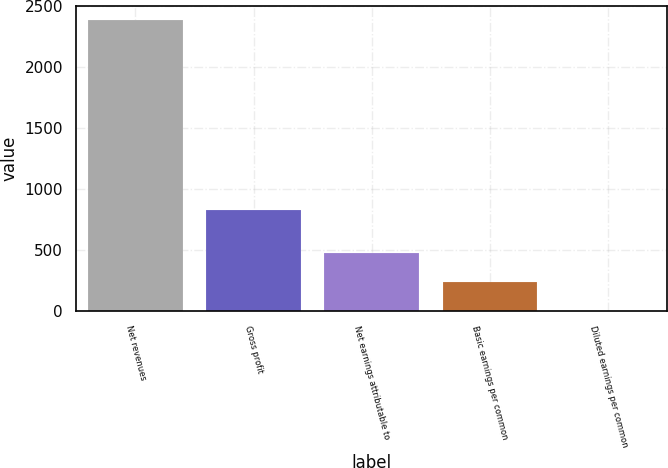Convert chart to OTSL. <chart><loc_0><loc_0><loc_500><loc_500><bar_chart><fcel>Net revenues<fcel>Gross profit<fcel>Net earnings attributable to<fcel>Basic earnings per common<fcel>Diluted earnings per common<nl><fcel>2382<fcel>826.8<fcel>477.96<fcel>239.96<fcel>1.96<nl></chart> 